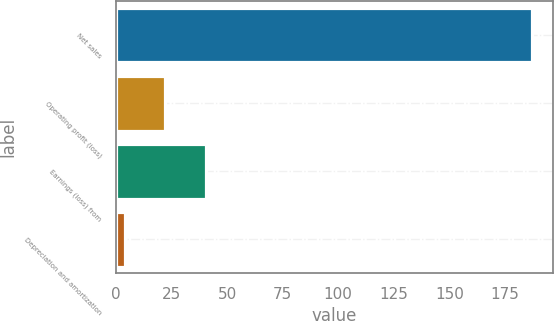Convert chart to OTSL. <chart><loc_0><loc_0><loc_500><loc_500><bar_chart><fcel>Net sales<fcel>Operating profit (loss)<fcel>Earnings (loss) from<fcel>Depreciation and amortization<nl><fcel>187<fcel>22.3<fcel>40.6<fcel>4<nl></chart> 